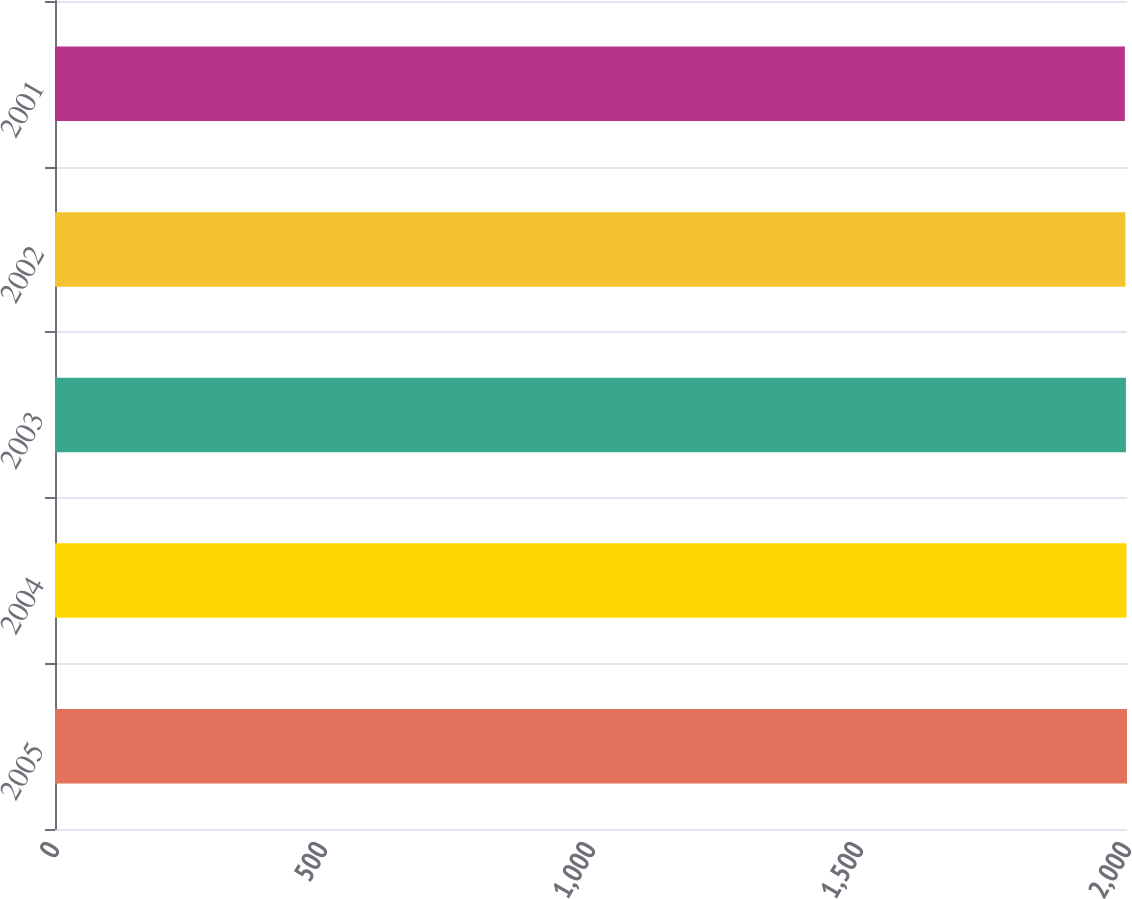Convert chart. <chart><loc_0><loc_0><loc_500><loc_500><bar_chart><fcel>2005<fcel>2004<fcel>2003<fcel>2002<fcel>2001<nl><fcel>2000<fcel>1999<fcel>1998<fcel>1997<fcel>1996<nl></chart> 